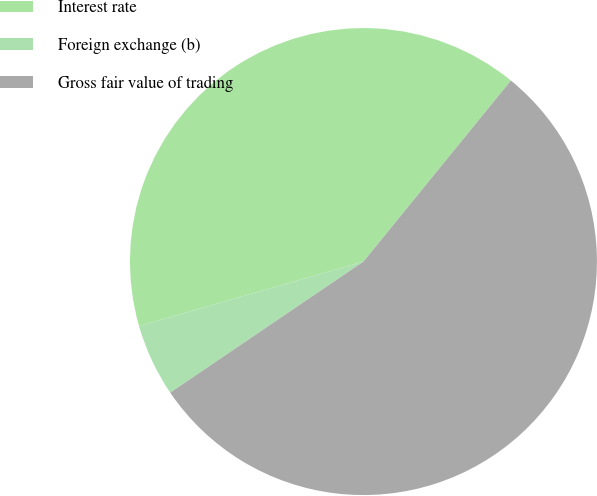Convert chart to OTSL. <chart><loc_0><loc_0><loc_500><loc_500><pie_chart><fcel>Interest rate<fcel>Foreign exchange (b)<fcel>Gross fair value of trading<nl><fcel>40.33%<fcel>5.04%<fcel>54.64%<nl></chart> 